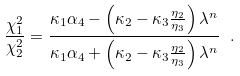<formula> <loc_0><loc_0><loc_500><loc_500>\frac { \chi _ { 1 } ^ { 2 } } { \chi _ { 2 } ^ { 2 } } = \frac { \kappa _ { 1 } \alpha _ { 4 } - \left ( \kappa _ { 2 } - \kappa _ { 3 } \frac { \eta _ { 2 } } { \eta _ { 3 } } \right ) \lambda ^ { n } } { \kappa _ { 1 } \alpha _ { 4 } + \left ( \kappa _ { 2 } - \kappa _ { 3 } \frac { \eta _ { 2 } } { \eta _ { 3 } } \right ) \lambda ^ { n } } \ .</formula> 